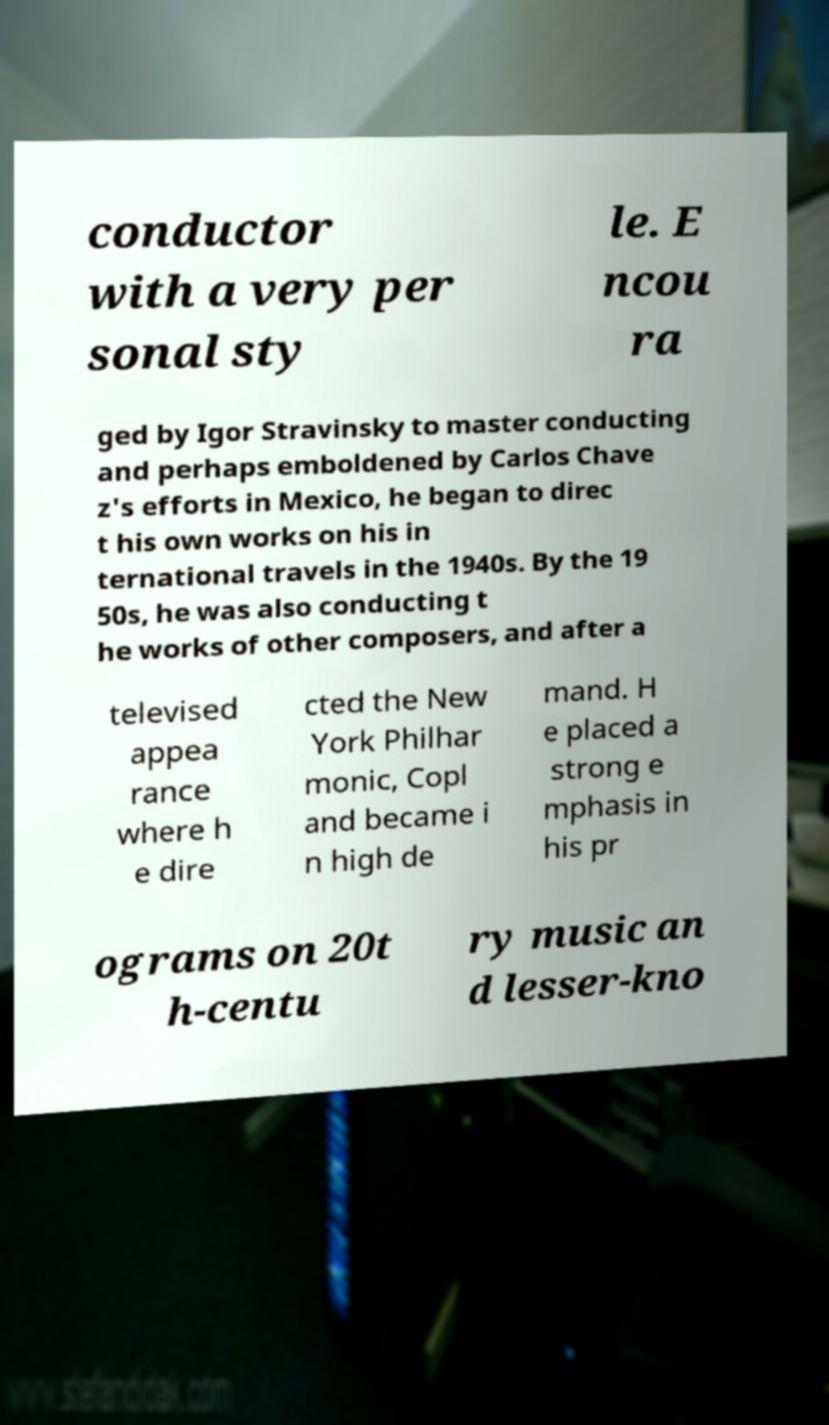I need the written content from this picture converted into text. Can you do that? conductor with a very per sonal sty le. E ncou ra ged by Igor Stravinsky to master conducting and perhaps emboldened by Carlos Chave z's efforts in Mexico, he began to direc t his own works on his in ternational travels in the 1940s. By the 19 50s, he was also conducting t he works of other composers, and after a televised appea rance where h e dire cted the New York Philhar monic, Copl and became i n high de mand. H e placed a strong e mphasis in his pr ograms on 20t h-centu ry music an d lesser-kno 